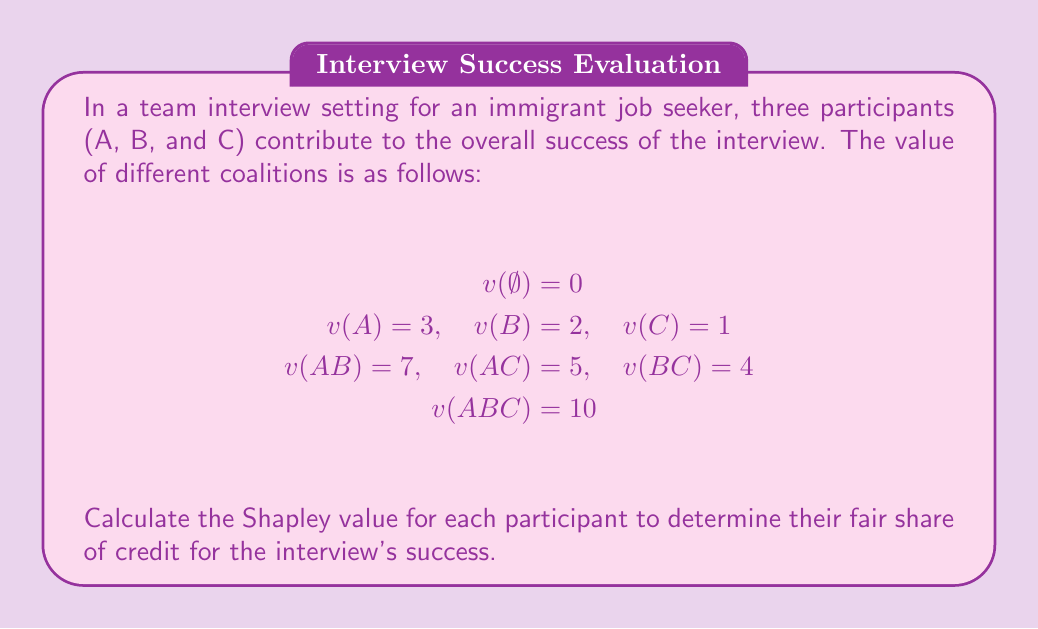Show me your answer to this math problem. To calculate the Shapley value, we need to determine the marginal contribution of each player in all possible orderings. There are 3! = 6 possible orderings for three players.

1. Calculate marginal contributions for each ordering:

   ABC: A(3), B(4), C(3)
   ACB: A(3), C(2), B(5)
   BAC: B(2), A(5), C(3)
   BCA: B(2), C(2), A(6)
   CAB: C(1), A(4), B(5)
   CBA: C(1), B(3), A(6)

2. Sum up the marginal contributions for each player:

   A: 3 + 3 + 5 + 6 + 4 + 6 = 27
   B: 4 + 5 + 2 + 2 + 5 + 3 = 21
   C: 3 + 2 + 3 + 2 + 1 + 1 = 12

3. Calculate the Shapley value by dividing the sum by the number of orderings (6):

   $$\phi_A = \frac{27}{6} = 4.5$$
   $$\phi_B = \frac{21}{6} = 3.5$$
   $$\phi_C = \frac{12}{6} = 2$$

The Shapley values represent the fair allocation of credit to each participant based on their average marginal contributions across all possible orderings.
Answer: The Shapley values for participants A, B, and C are:

$$\phi_A = 4.5$$
$$\phi_B = 3.5$$
$$\phi_C = 2$$ 